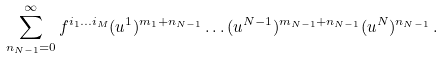<formula> <loc_0><loc_0><loc_500><loc_500>\sum ^ { \infty } _ { n _ { N - 1 } = 0 } f ^ { i _ { 1 } \dots i _ { M } } ( u ^ { 1 } ) ^ { m _ { 1 } + n _ { N - 1 } } \dots ( u ^ { N - 1 } ) ^ { m _ { N - 1 } + n _ { N - 1 } } ( u ^ { N } ) ^ { n _ { N - 1 } } \, .</formula> 